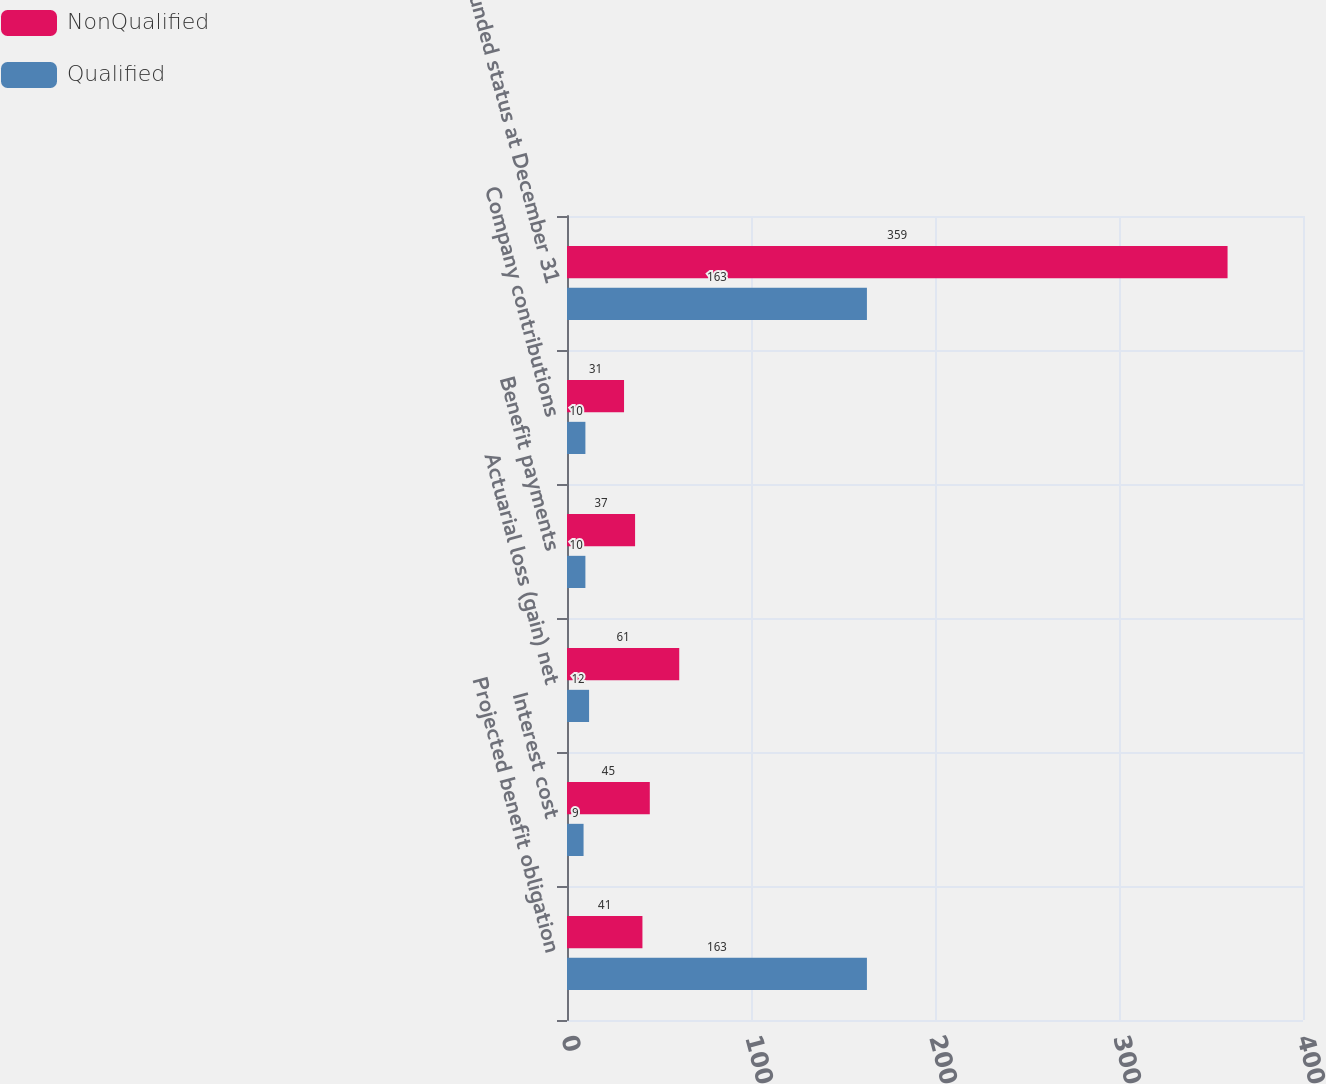Convert chart to OTSL. <chart><loc_0><loc_0><loc_500><loc_500><stacked_bar_chart><ecel><fcel>Projected benefit obligation<fcel>Interest cost<fcel>Actuarial loss (gain) net<fcel>Benefit payments<fcel>Company contributions<fcel>Funded status at December 31<nl><fcel>NonQualified<fcel>41<fcel>45<fcel>61<fcel>37<fcel>31<fcel>359<nl><fcel>Qualified<fcel>163<fcel>9<fcel>12<fcel>10<fcel>10<fcel>163<nl></chart> 